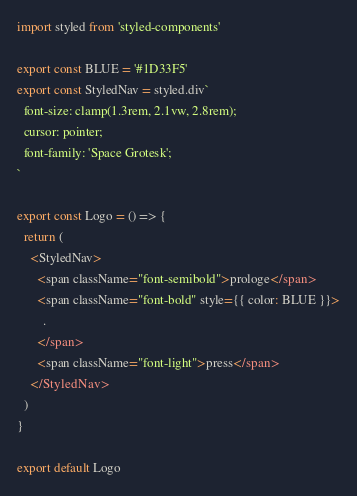<code> <loc_0><loc_0><loc_500><loc_500><_JavaScript_>import styled from 'styled-components'

export const BLUE = '#1D33F5'
export const StyledNav = styled.div`
  font-size: clamp(1.3rem, 2.1vw, 2.8rem);
  cursor: pointer;
  font-family: 'Space Grotesk';
`

export const Logo = () => {
  return (
    <StyledNav>
      <span className="font-semibold">prologe</span>
      <span className="font-bold" style={{ color: BLUE }}>
        .
      </span>
      <span className="font-light">press</span>
    </StyledNav>
  )
}

export default Logo
</code> 